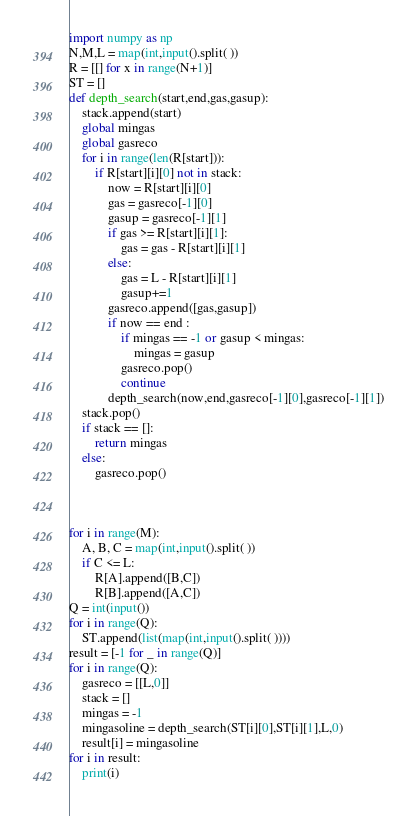Convert code to text. <code><loc_0><loc_0><loc_500><loc_500><_Python_>import numpy as np
N,M,L = map(int,input().split( ))
R = [[] for x in range(N+1)]
ST = []
def depth_search(start,end,gas,gasup):
    stack.append(start)
    global mingas
    global gasreco
    for i in range(len(R[start])):
        if R[start][i][0] not in stack:
            now = R[start][i][0]
            gas = gasreco[-1][0]
            gasup = gasreco[-1][1]
            if gas >= R[start][i][1]:
                gas = gas - R[start][i][1]
            else:
                gas = L - R[start][i][1]
                gasup+=1
            gasreco.append([gas,gasup])
            if now == end :
                if mingas == -1 or gasup < mingas:
                    mingas = gasup
                gasreco.pop()
                continue
            depth_search(now,end,gasreco[-1][0],gasreco[-1][1])
    stack.pop()
    if stack == []:
        return mingas
    else:
        gasreco.pop()



for i in range(M):
    A, B, C = map(int,input().split( ))
    if C <= L:
        R[A].append([B,C])
        R[B].append([A,C])
Q = int(input())
for i in range(Q):
    ST.append(list(map(int,input().split( ))))
result = [-1 for _ in range(Q)]
for i in range(Q):
    gasreco = [[L,0]]
    stack = []
    mingas = -1
    mingasoline = depth_search(ST[i][0],ST[i][1],L,0)
    result[i] = mingasoline
for i in result:
    print(i) 

</code> 